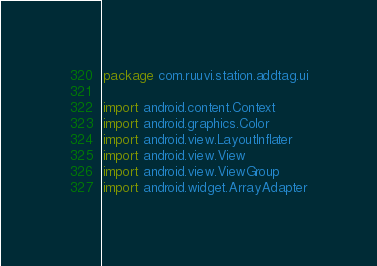Convert code to text. <code><loc_0><loc_0><loc_500><loc_500><_Kotlin_>package com.ruuvi.station.addtag.ui

import android.content.Context
import android.graphics.Color
import android.view.LayoutInflater
import android.view.View
import android.view.ViewGroup
import android.widget.ArrayAdapter</code> 